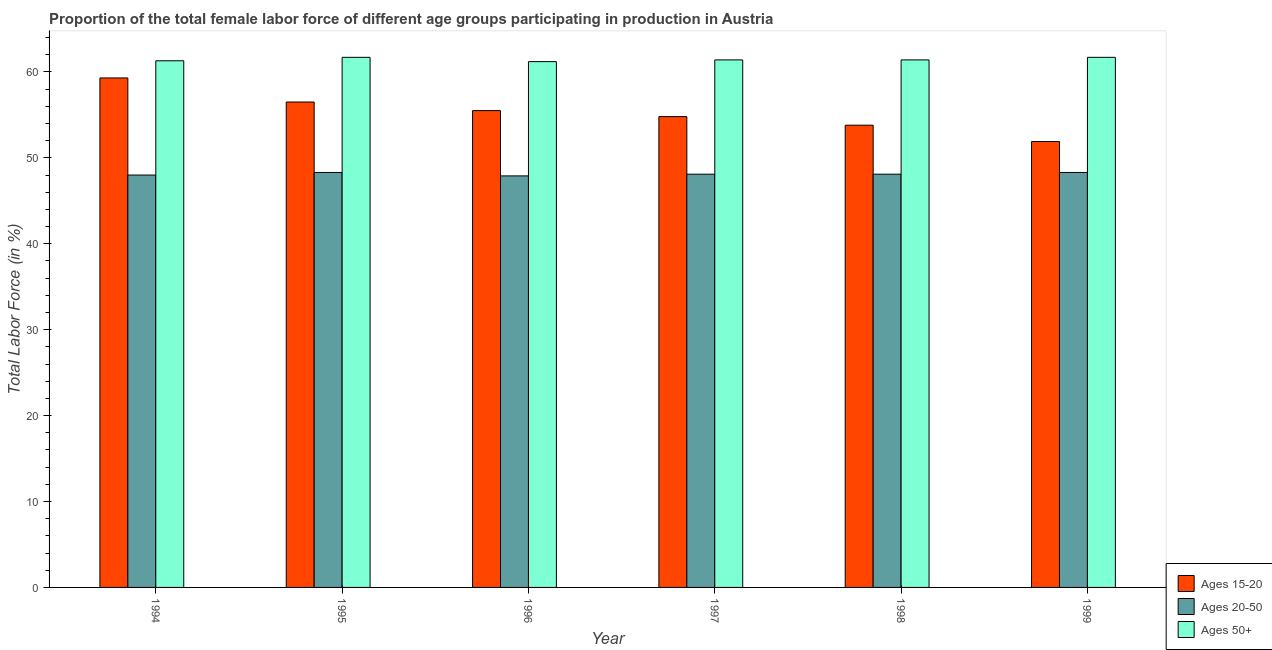How many different coloured bars are there?
Your answer should be compact. 3. How many groups of bars are there?
Give a very brief answer. 6. How many bars are there on the 5th tick from the right?
Ensure brevity in your answer.  3. What is the label of the 5th group of bars from the left?
Keep it short and to the point. 1998. What is the percentage of female labor force within the age group 15-20 in 1997?
Make the answer very short. 54.8. Across all years, what is the maximum percentage of female labor force within the age group 20-50?
Give a very brief answer. 48.3. Across all years, what is the minimum percentage of female labor force within the age group 20-50?
Your answer should be compact. 47.9. What is the total percentage of female labor force above age 50 in the graph?
Ensure brevity in your answer.  368.7. What is the difference between the percentage of female labor force within the age group 20-50 in 1994 and that in 1996?
Give a very brief answer. 0.1. What is the difference between the percentage of female labor force within the age group 20-50 in 1996 and the percentage of female labor force within the age group 15-20 in 1997?
Give a very brief answer. -0.2. What is the average percentage of female labor force within the age group 20-50 per year?
Make the answer very short. 48.12. In the year 1997, what is the difference between the percentage of female labor force within the age group 20-50 and percentage of female labor force within the age group 15-20?
Your answer should be very brief. 0. What is the ratio of the percentage of female labor force within the age group 15-20 in 1994 to that in 1999?
Your response must be concise. 1.14. Is the difference between the percentage of female labor force within the age group 20-50 in 1996 and 1999 greater than the difference between the percentage of female labor force within the age group 15-20 in 1996 and 1999?
Offer a very short reply. No. What is the difference between the highest and the second highest percentage of female labor force within the age group 20-50?
Provide a short and direct response. 0. What is the difference between the highest and the lowest percentage of female labor force within the age group 20-50?
Offer a terse response. 0.4. In how many years, is the percentage of female labor force above age 50 greater than the average percentage of female labor force above age 50 taken over all years?
Your response must be concise. 2. Is the sum of the percentage of female labor force within the age group 20-50 in 1997 and 1998 greater than the maximum percentage of female labor force within the age group 15-20 across all years?
Keep it short and to the point. Yes. What does the 3rd bar from the left in 1995 represents?
Ensure brevity in your answer.  Ages 50+. What does the 1st bar from the right in 1996 represents?
Your answer should be very brief. Ages 50+. How many bars are there?
Your answer should be very brief. 18. How many years are there in the graph?
Offer a terse response. 6. What is the difference between two consecutive major ticks on the Y-axis?
Provide a succinct answer. 10. Does the graph contain any zero values?
Your answer should be compact. No. Does the graph contain grids?
Offer a very short reply. No. Where does the legend appear in the graph?
Offer a very short reply. Bottom right. What is the title of the graph?
Offer a very short reply. Proportion of the total female labor force of different age groups participating in production in Austria. What is the label or title of the X-axis?
Keep it short and to the point. Year. What is the label or title of the Y-axis?
Your answer should be compact. Total Labor Force (in %). What is the Total Labor Force (in %) of Ages 15-20 in 1994?
Your answer should be very brief. 59.3. What is the Total Labor Force (in %) of Ages 20-50 in 1994?
Your response must be concise. 48. What is the Total Labor Force (in %) in Ages 50+ in 1994?
Your response must be concise. 61.3. What is the Total Labor Force (in %) of Ages 15-20 in 1995?
Ensure brevity in your answer.  56.5. What is the Total Labor Force (in %) of Ages 20-50 in 1995?
Provide a short and direct response. 48.3. What is the Total Labor Force (in %) in Ages 50+ in 1995?
Your response must be concise. 61.7. What is the Total Labor Force (in %) in Ages 15-20 in 1996?
Your answer should be compact. 55.5. What is the Total Labor Force (in %) of Ages 20-50 in 1996?
Ensure brevity in your answer.  47.9. What is the Total Labor Force (in %) of Ages 50+ in 1996?
Your response must be concise. 61.2. What is the Total Labor Force (in %) in Ages 15-20 in 1997?
Your response must be concise. 54.8. What is the Total Labor Force (in %) of Ages 20-50 in 1997?
Keep it short and to the point. 48.1. What is the Total Labor Force (in %) of Ages 50+ in 1997?
Provide a short and direct response. 61.4. What is the Total Labor Force (in %) of Ages 15-20 in 1998?
Your answer should be compact. 53.8. What is the Total Labor Force (in %) of Ages 20-50 in 1998?
Offer a very short reply. 48.1. What is the Total Labor Force (in %) in Ages 50+ in 1998?
Offer a very short reply. 61.4. What is the Total Labor Force (in %) of Ages 15-20 in 1999?
Your answer should be compact. 51.9. What is the Total Labor Force (in %) in Ages 20-50 in 1999?
Your answer should be very brief. 48.3. What is the Total Labor Force (in %) in Ages 50+ in 1999?
Give a very brief answer. 61.7. Across all years, what is the maximum Total Labor Force (in %) of Ages 15-20?
Your response must be concise. 59.3. Across all years, what is the maximum Total Labor Force (in %) of Ages 20-50?
Keep it short and to the point. 48.3. Across all years, what is the maximum Total Labor Force (in %) of Ages 50+?
Your response must be concise. 61.7. Across all years, what is the minimum Total Labor Force (in %) of Ages 15-20?
Provide a succinct answer. 51.9. Across all years, what is the minimum Total Labor Force (in %) of Ages 20-50?
Give a very brief answer. 47.9. Across all years, what is the minimum Total Labor Force (in %) in Ages 50+?
Offer a terse response. 61.2. What is the total Total Labor Force (in %) of Ages 15-20 in the graph?
Provide a short and direct response. 331.8. What is the total Total Labor Force (in %) in Ages 20-50 in the graph?
Your answer should be very brief. 288.7. What is the total Total Labor Force (in %) in Ages 50+ in the graph?
Your answer should be compact. 368.7. What is the difference between the Total Labor Force (in %) of Ages 15-20 in 1994 and that in 1995?
Your answer should be compact. 2.8. What is the difference between the Total Labor Force (in %) of Ages 50+ in 1994 and that in 1995?
Offer a very short reply. -0.4. What is the difference between the Total Labor Force (in %) of Ages 50+ in 1994 and that in 1996?
Offer a terse response. 0.1. What is the difference between the Total Labor Force (in %) in Ages 15-20 in 1994 and that in 1997?
Make the answer very short. 4.5. What is the difference between the Total Labor Force (in %) in Ages 50+ in 1994 and that in 1997?
Your answer should be very brief. -0.1. What is the difference between the Total Labor Force (in %) in Ages 20-50 in 1994 and that in 1998?
Your answer should be very brief. -0.1. What is the difference between the Total Labor Force (in %) of Ages 50+ in 1994 and that in 1999?
Offer a very short reply. -0.4. What is the difference between the Total Labor Force (in %) in Ages 15-20 in 1995 and that in 1996?
Keep it short and to the point. 1. What is the difference between the Total Labor Force (in %) of Ages 15-20 in 1995 and that in 1997?
Your answer should be very brief. 1.7. What is the difference between the Total Labor Force (in %) in Ages 20-50 in 1995 and that in 1997?
Make the answer very short. 0.2. What is the difference between the Total Labor Force (in %) of Ages 20-50 in 1996 and that in 1997?
Give a very brief answer. -0.2. What is the difference between the Total Labor Force (in %) in Ages 50+ in 1996 and that in 1997?
Provide a succinct answer. -0.2. What is the difference between the Total Labor Force (in %) of Ages 15-20 in 1996 and that in 1998?
Provide a short and direct response. 1.7. What is the difference between the Total Labor Force (in %) in Ages 20-50 in 1996 and that in 1998?
Provide a succinct answer. -0.2. What is the difference between the Total Labor Force (in %) of Ages 20-50 in 1996 and that in 1999?
Ensure brevity in your answer.  -0.4. What is the difference between the Total Labor Force (in %) in Ages 20-50 in 1997 and that in 1998?
Ensure brevity in your answer.  0. What is the difference between the Total Labor Force (in %) of Ages 50+ in 1997 and that in 1998?
Provide a succinct answer. 0. What is the difference between the Total Labor Force (in %) of Ages 15-20 in 1997 and that in 1999?
Your answer should be compact. 2.9. What is the difference between the Total Labor Force (in %) of Ages 20-50 in 1997 and that in 1999?
Provide a short and direct response. -0.2. What is the difference between the Total Labor Force (in %) of Ages 15-20 in 1998 and that in 1999?
Keep it short and to the point. 1.9. What is the difference between the Total Labor Force (in %) of Ages 15-20 in 1994 and the Total Labor Force (in %) of Ages 50+ in 1995?
Keep it short and to the point. -2.4. What is the difference between the Total Labor Force (in %) in Ages 20-50 in 1994 and the Total Labor Force (in %) in Ages 50+ in 1995?
Your answer should be compact. -13.7. What is the difference between the Total Labor Force (in %) in Ages 20-50 in 1994 and the Total Labor Force (in %) in Ages 50+ in 1996?
Your response must be concise. -13.2. What is the difference between the Total Labor Force (in %) of Ages 15-20 in 1994 and the Total Labor Force (in %) of Ages 20-50 in 1997?
Your answer should be very brief. 11.2. What is the difference between the Total Labor Force (in %) of Ages 15-20 in 1994 and the Total Labor Force (in %) of Ages 20-50 in 1999?
Your answer should be very brief. 11. What is the difference between the Total Labor Force (in %) of Ages 15-20 in 1994 and the Total Labor Force (in %) of Ages 50+ in 1999?
Keep it short and to the point. -2.4. What is the difference between the Total Labor Force (in %) in Ages 20-50 in 1994 and the Total Labor Force (in %) in Ages 50+ in 1999?
Your answer should be very brief. -13.7. What is the difference between the Total Labor Force (in %) of Ages 15-20 in 1995 and the Total Labor Force (in %) of Ages 20-50 in 1996?
Give a very brief answer. 8.6. What is the difference between the Total Labor Force (in %) of Ages 15-20 in 1995 and the Total Labor Force (in %) of Ages 50+ in 1997?
Offer a terse response. -4.9. What is the difference between the Total Labor Force (in %) of Ages 20-50 in 1995 and the Total Labor Force (in %) of Ages 50+ in 1997?
Provide a succinct answer. -13.1. What is the difference between the Total Labor Force (in %) in Ages 15-20 in 1995 and the Total Labor Force (in %) in Ages 20-50 in 1998?
Your answer should be compact. 8.4. What is the difference between the Total Labor Force (in %) of Ages 20-50 in 1995 and the Total Labor Force (in %) of Ages 50+ in 1998?
Your response must be concise. -13.1. What is the difference between the Total Labor Force (in %) in Ages 15-20 in 1995 and the Total Labor Force (in %) in Ages 20-50 in 1999?
Your answer should be very brief. 8.2. What is the difference between the Total Labor Force (in %) in Ages 15-20 in 1995 and the Total Labor Force (in %) in Ages 50+ in 1999?
Ensure brevity in your answer.  -5.2. What is the difference between the Total Labor Force (in %) in Ages 20-50 in 1996 and the Total Labor Force (in %) in Ages 50+ in 1997?
Give a very brief answer. -13.5. What is the difference between the Total Labor Force (in %) of Ages 15-20 in 1996 and the Total Labor Force (in %) of Ages 50+ in 1998?
Offer a terse response. -5.9. What is the difference between the Total Labor Force (in %) in Ages 20-50 in 1996 and the Total Labor Force (in %) in Ages 50+ in 1998?
Make the answer very short. -13.5. What is the difference between the Total Labor Force (in %) of Ages 20-50 in 1996 and the Total Labor Force (in %) of Ages 50+ in 1999?
Make the answer very short. -13.8. What is the difference between the Total Labor Force (in %) of Ages 20-50 in 1997 and the Total Labor Force (in %) of Ages 50+ in 1998?
Make the answer very short. -13.3. What is the difference between the Total Labor Force (in %) of Ages 15-20 in 1997 and the Total Labor Force (in %) of Ages 20-50 in 1999?
Offer a very short reply. 6.5. What is the difference between the Total Labor Force (in %) in Ages 15-20 in 1997 and the Total Labor Force (in %) in Ages 50+ in 1999?
Offer a terse response. -6.9. What is the difference between the Total Labor Force (in %) of Ages 20-50 in 1997 and the Total Labor Force (in %) of Ages 50+ in 1999?
Provide a succinct answer. -13.6. What is the difference between the Total Labor Force (in %) of Ages 20-50 in 1998 and the Total Labor Force (in %) of Ages 50+ in 1999?
Offer a terse response. -13.6. What is the average Total Labor Force (in %) of Ages 15-20 per year?
Your answer should be very brief. 55.3. What is the average Total Labor Force (in %) in Ages 20-50 per year?
Offer a very short reply. 48.12. What is the average Total Labor Force (in %) in Ages 50+ per year?
Keep it short and to the point. 61.45. In the year 1994, what is the difference between the Total Labor Force (in %) in Ages 15-20 and Total Labor Force (in %) in Ages 20-50?
Your response must be concise. 11.3. In the year 1994, what is the difference between the Total Labor Force (in %) in Ages 20-50 and Total Labor Force (in %) in Ages 50+?
Offer a terse response. -13.3. In the year 1995, what is the difference between the Total Labor Force (in %) of Ages 15-20 and Total Labor Force (in %) of Ages 50+?
Make the answer very short. -5.2. In the year 1996, what is the difference between the Total Labor Force (in %) in Ages 15-20 and Total Labor Force (in %) in Ages 20-50?
Your answer should be very brief. 7.6. In the year 1996, what is the difference between the Total Labor Force (in %) in Ages 20-50 and Total Labor Force (in %) in Ages 50+?
Ensure brevity in your answer.  -13.3. In the year 1997, what is the difference between the Total Labor Force (in %) of Ages 15-20 and Total Labor Force (in %) of Ages 50+?
Ensure brevity in your answer.  -6.6. In the year 1997, what is the difference between the Total Labor Force (in %) of Ages 20-50 and Total Labor Force (in %) of Ages 50+?
Your answer should be very brief. -13.3. In the year 1998, what is the difference between the Total Labor Force (in %) of Ages 15-20 and Total Labor Force (in %) of Ages 20-50?
Offer a terse response. 5.7. In the year 1998, what is the difference between the Total Labor Force (in %) of Ages 15-20 and Total Labor Force (in %) of Ages 50+?
Provide a short and direct response. -7.6. In the year 1999, what is the difference between the Total Labor Force (in %) in Ages 15-20 and Total Labor Force (in %) in Ages 50+?
Ensure brevity in your answer.  -9.8. In the year 1999, what is the difference between the Total Labor Force (in %) in Ages 20-50 and Total Labor Force (in %) in Ages 50+?
Give a very brief answer. -13.4. What is the ratio of the Total Labor Force (in %) in Ages 15-20 in 1994 to that in 1995?
Offer a terse response. 1.05. What is the ratio of the Total Labor Force (in %) in Ages 50+ in 1994 to that in 1995?
Ensure brevity in your answer.  0.99. What is the ratio of the Total Labor Force (in %) of Ages 15-20 in 1994 to that in 1996?
Offer a terse response. 1.07. What is the ratio of the Total Labor Force (in %) in Ages 50+ in 1994 to that in 1996?
Ensure brevity in your answer.  1. What is the ratio of the Total Labor Force (in %) in Ages 15-20 in 1994 to that in 1997?
Provide a succinct answer. 1.08. What is the ratio of the Total Labor Force (in %) in Ages 20-50 in 1994 to that in 1997?
Keep it short and to the point. 1. What is the ratio of the Total Labor Force (in %) in Ages 50+ in 1994 to that in 1997?
Keep it short and to the point. 1. What is the ratio of the Total Labor Force (in %) in Ages 15-20 in 1994 to that in 1998?
Provide a short and direct response. 1.1. What is the ratio of the Total Labor Force (in %) of Ages 20-50 in 1994 to that in 1998?
Offer a very short reply. 1. What is the ratio of the Total Labor Force (in %) of Ages 15-20 in 1994 to that in 1999?
Keep it short and to the point. 1.14. What is the ratio of the Total Labor Force (in %) of Ages 15-20 in 1995 to that in 1996?
Your response must be concise. 1.02. What is the ratio of the Total Labor Force (in %) in Ages 20-50 in 1995 to that in 1996?
Your answer should be very brief. 1.01. What is the ratio of the Total Labor Force (in %) of Ages 50+ in 1995 to that in 1996?
Your response must be concise. 1.01. What is the ratio of the Total Labor Force (in %) of Ages 15-20 in 1995 to that in 1997?
Ensure brevity in your answer.  1.03. What is the ratio of the Total Labor Force (in %) of Ages 15-20 in 1995 to that in 1998?
Offer a terse response. 1.05. What is the ratio of the Total Labor Force (in %) of Ages 50+ in 1995 to that in 1998?
Provide a short and direct response. 1. What is the ratio of the Total Labor Force (in %) in Ages 15-20 in 1995 to that in 1999?
Your response must be concise. 1.09. What is the ratio of the Total Labor Force (in %) of Ages 20-50 in 1995 to that in 1999?
Keep it short and to the point. 1. What is the ratio of the Total Labor Force (in %) in Ages 50+ in 1995 to that in 1999?
Make the answer very short. 1. What is the ratio of the Total Labor Force (in %) of Ages 15-20 in 1996 to that in 1997?
Make the answer very short. 1.01. What is the ratio of the Total Labor Force (in %) in Ages 20-50 in 1996 to that in 1997?
Make the answer very short. 1. What is the ratio of the Total Labor Force (in %) of Ages 50+ in 1996 to that in 1997?
Offer a very short reply. 1. What is the ratio of the Total Labor Force (in %) in Ages 15-20 in 1996 to that in 1998?
Your answer should be compact. 1.03. What is the ratio of the Total Labor Force (in %) of Ages 20-50 in 1996 to that in 1998?
Keep it short and to the point. 1. What is the ratio of the Total Labor Force (in %) of Ages 15-20 in 1996 to that in 1999?
Keep it short and to the point. 1.07. What is the ratio of the Total Labor Force (in %) of Ages 15-20 in 1997 to that in 1998?
Offer a terse response. 1.02. What is the ratio of the Total Labor Force (in %) in Ages 20-50 in 1997 to that in 1998?
Provide a short and direct response. 1. What is the ratio of the Total Labor Force (in %) of Ages 50+ in 1997 to that in 1998?
Keep it short and to the point. 1. What is the ratio of the Total Labor Force (in %) of Ages 15-20 in 1997 to that in 1999?
Provide a succinct answer. 1.06. What is the ratio of the Total Labor Force (in %) in Ages 20-50 in 1997 to that in 1999?
Your answer should be compact. 1. What is the ratio of the Total Labor Force (in %) in Ages 15-20 in 1998 to that in 1999?
Provide a succinct answer. 1.04. What is the ratio of the Total Labor Force (in %) in Ages 20-50 in 1998 to that in 1999?
Give a very brief answer. 1. What is the difference between the highest and the second highest Total Labor Force (in %) of Ages 15-20?
Offer a very short reply. 2.8. What is the difference between the highest and the second highest Total Labor Force (in %) in Ages 20-50?
Make the answer very short. 0. What is the difference between the highest and the lowest Total Labor Force (in %) of Ages 20-50?
Your response must be concise. 0.4. 